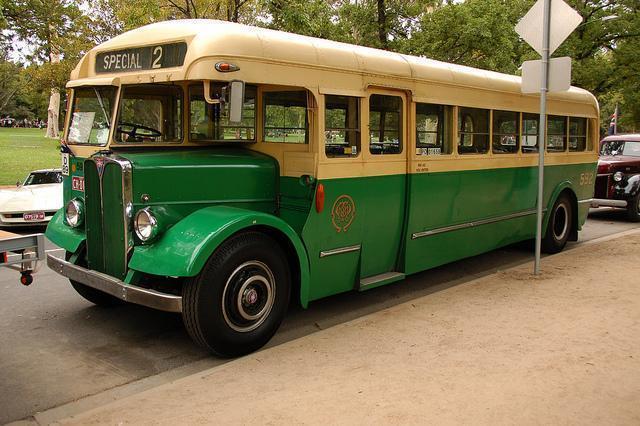Where will the passengers enter?
Choose the correct response and explain in the format: 'Answer: answer
Rationale: rationale.'
Options: Rear, side, top, front. Answer: side.
Rationale: The passengers go on the side. 